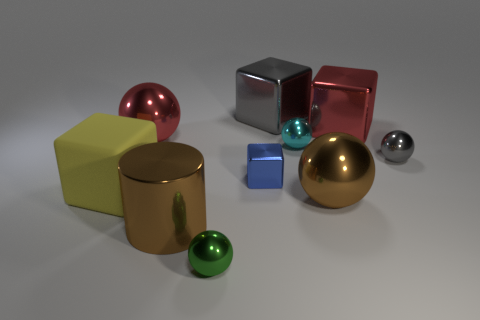How many spheres are both behind the tiny blue object and in front of the yellow matte cube?
Your answer should be compact. 0. What is the color of the small cube?
Give a very brief answer. Blue. What is the material of the red thing that is the same shape as the green shiny thing?
Provide a short and direct response. Metal. Is there any other thing that has the same material as the large cylinder?
Offer a very short reply. Yes. Do the big matte cube and the small metallic cube have the same color?
Provide a short and direct response. No. There is a brown metal thing that is right of the tiny object in front of the yellow thing; what shape is it?
Keep it short and to the point. Sphere. What is the shape of the tiny blue thing that is the same material as the large red cube?
Offer a terse response. Cube. What number of other things are the same shape as the rubber thing?
Give a very brief answer. 3. There is a green metallic object that is in front of the red metal cube; is it the same size as the cyan object?
Provide a succinct answer. Yes. Are there more metal balls right of the small green ball than big matte objects?
Keep it short and to the point. Yes. 